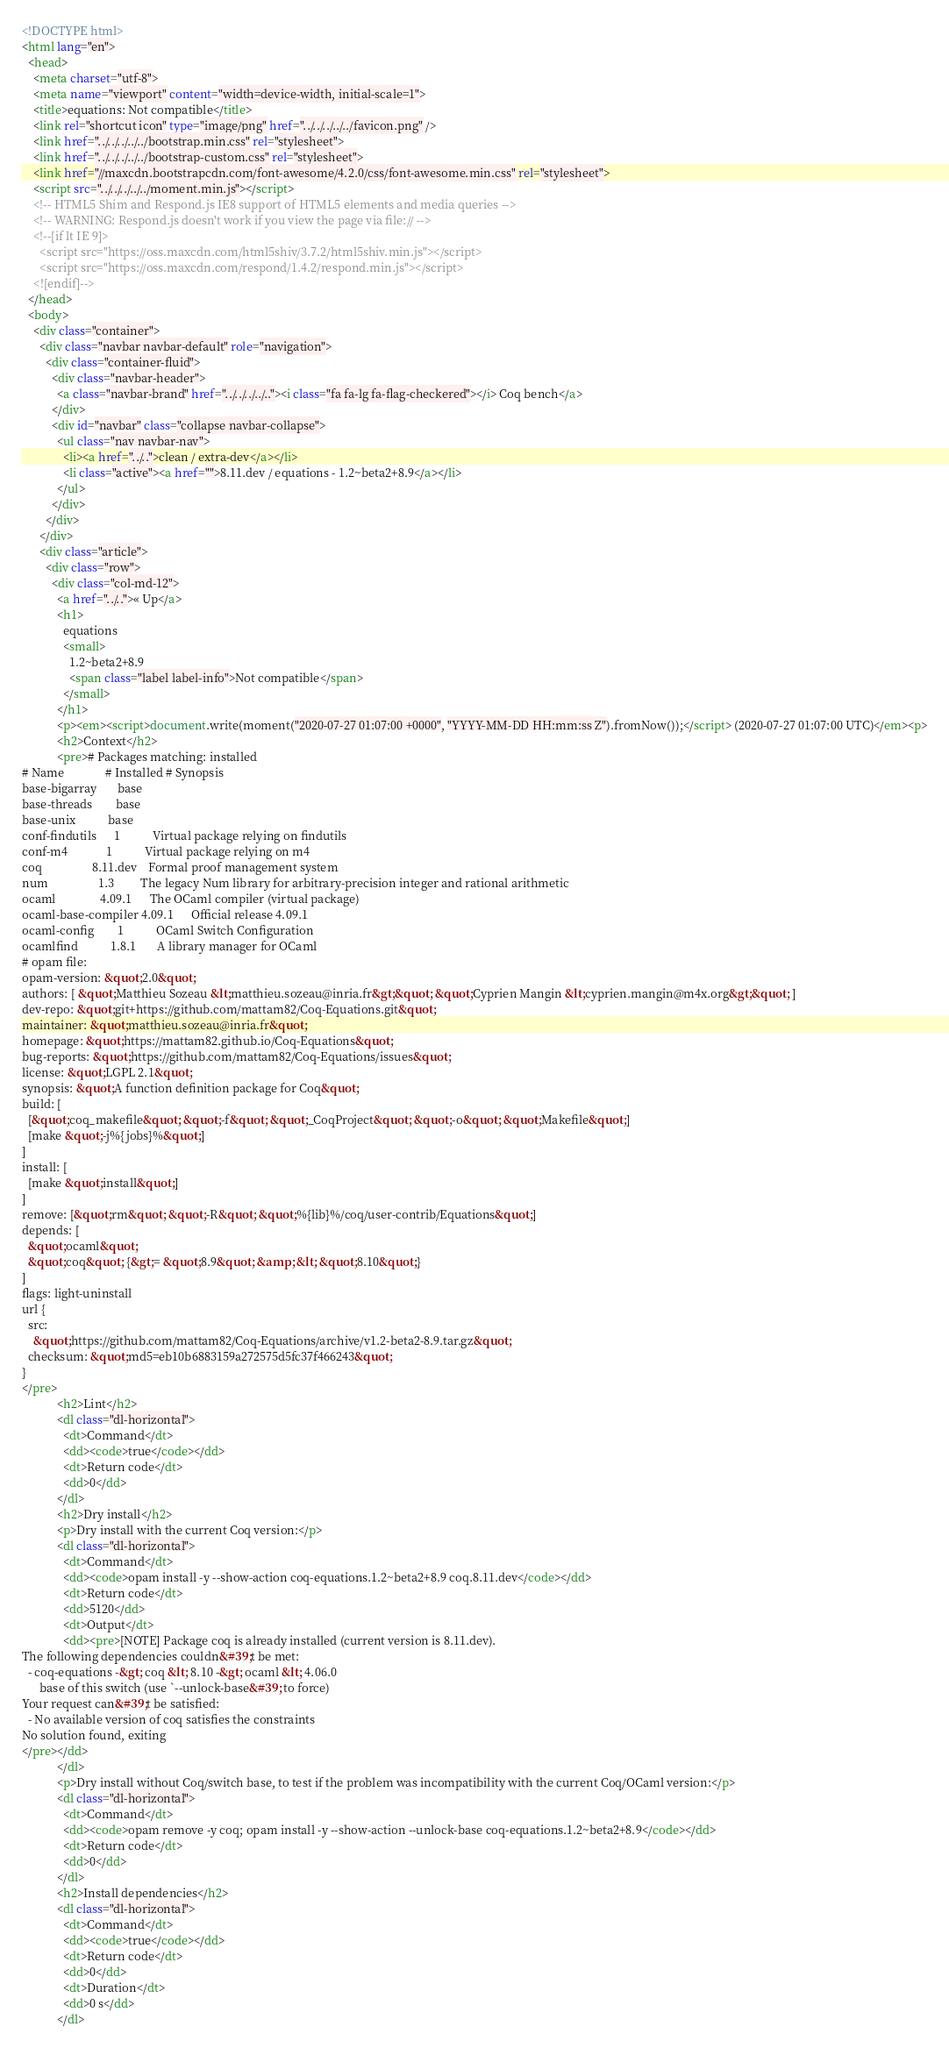Convert code to text. <code><loc_0><loc_0><loc_500><loc_500><_HTML_><!DOCTYPE html>
<html lang="en">
  <head>
    <meta charset="utf-8">
    <meta name="viewport" content="width=device-width, initial-scale=1">
    <title>equations: Not compatible</title>
    <link rel="shortcut icon" type="image/png" href="../../../../../favicon.png" />
    <link href="../../../../../bootstrap.min.css" rel="stylesheet">
    <link href="../../../../../bootstrap-custom.css" rel="stylesheet">
    <link href="//maxcdn.bootstrapcdn.com/font-awesome/4.2.0/css/font-awesome.min.css" rel="stylesheet">
    <script src="../../../../../moment.min.js"></script>
    <!-- HTML5 Shim and Respond.js IE8 support of HTML5 elements and media queries -->
    <!-- WARNING: Respond.js doesn't work if you view the page via file:// -->
    <!--[if lt IE 9]>
      <script src="https://oss.maxcdn.com/html5shiv/3.7.2/html5shiv.min.js"></script>
      <script src="https://oss.maxcdn.com/respond/1.4.2/respond.min.js"></script>
    <![endif]-->
  </head>
  <body>
    <div class="container">
      <div class="navbar navbar-default" role="navigation">
        <div class="container-fluid">
          <div class="navbar-header">
            <a class="navbar-brand" href="../../../../.."><i class="fa fa-lg fa-flag-checkered"></i> Coq bench</a>
          </div>
          <div id="navbar" class="collapse navbar-collapse">
            <ul class="nav navbar-nav">
              <li><a href="../..">clean / extra-dev</a></li>
              <li class="active"><a href="">8.11.dev / equations - 1.2~beta2+8.9</a></li>
            </ul>
          </div>
        </div>
      </div>
      <div class="article">
        <div class="row">
          <div class="col-md-12">
            <a href="../..">« Up</a>
            <h1>
              equations
              <small>
                1.2~beta2+8.9
                <span class="label label-info">Not compatible</span>
              </small>
            </h1>
            <p><em><script>document.write(moment("2020-07-27 01:07:00 +0000", "YYYY-MM-DD HH:mm:ss Z").fromNow());</script> (2020-07-27 01:07:00 UTC)</em><p>
            <h2>Context</h2>
            <pre># Packages matching: installed
# Name              # Installed # Synopsis
base-bigarray       base
base-threads        base
base-unix           base
conf-findutils      1           Virtual package relying on findutils
conf-m4             1           Virtual package relying on m4
coq                 8.11.dev    Formal proof management system
num                 1.3         The legacy Num library for arbitrary-precision integer and rational arithmetic
ocaml               4.09.1      The OCaml compiler (virtual package)
ocaml-base-compiler 4.09.1      Official release 4.09.1
ocaml-config        1           OCaml Switch Configuration
ocamlfind           1.8.1       A library manager for OCaml
# opam file:
opam-version: &quot;2.0&quot;
authors: [ &quot;Matthieu Sozeau &lt;matthieu.sozeau@inria.fr&gt;&quot; &quot;Cyprien Mangin &lt;cyprien.mangin@m4x.org&gt;&quot; ]
dev-repo: &quot;git+https://github.com/mattam82/Coq-Equations.git&quot;
maintainer: &quot;matthieu.sozeau@inria.fr&quot;
homepage: &quot;https://mattam82.github.io/Coq-Equations&quot;
bug-reports: &quot;https://github.com/mattam82/Coq-Equations/issues&quot;
license: &quot;LGPL 2.1&quot;
synopsis: &quot;A function definition package for Coq&quot;
build: [
  [&quot;coq_makefile&quot; &quot;-f&quot; &quot;_CoqProject&quot; &quot;-o&quot; &quot;Makefile&quot;]
  [make &quot;-j%{jobs}%&quot;]
]
install: [
  [make &quot;install&quot;]
]
remove: [&quot;rm&quot; &quot;-R&quot; &quot;%{lib}%/coq/user-contrib/Equations&quot;]
depends: [
  &quot;ocaml&quot;
  &quot;coq&quot; {&gt;= &quot;8.9&quot; &amp; &lt; &quot;8.10&quot;}
]
flags: light-uninstall
url {
  src:
    &quot;https://github.com/mattam82/Coq-Equations/archive/v1.2-beta2-8.9.tar.gz&quot;
  checksum: &quot;md5=eb10b6883159a272575d5fc37f466243&quot;
}
</pre>
            <h2>Lint</h2>
            <dl class="dl-horizontal">
              <dt>Command</dt>
              <dd><code>true</code></dd>
              <dt>Return code</dt>
              <dd>0</dd>
            </dl>
            <h2>Dry install</h2>
            <p>Dry install with the current Coq version:</p>
            <dl class="dl-horizontal">
              <dt>Command</dt>
              <dd><code>opam install -y --show-action coq-equations.1.2~beta2+8.9 coq.8.11.dev</code></dd>
              <dt>Return code</dt>
              <dd>5120</dd>
              <dt>Output</dt>
              <dd><pre>[NOTE] Package coq is already installed (current version is 8.11.dev).
The following dependencies couldn&#39;t be met:
  - coq-equations -&gt; coq &lt; 8.10 -&gt; ocaml &lt; 4.06.0
      base of this switch (use `--unlock-base&#39; to force)
Your request can&#39;t be satisfied:
  - No available version of coq satisfies the constraints
No solution found, exiting
</pre></dd>
            </dl>
            <p>Dry install without Coq/switch base, to test if the problem was incompatibility with the current Coq/OCaml version:</p>
            <dl class="dl-horizontal">
              <dt>Command</dt>
              <dd><code>opam remove -y coq; opam install -y --show-action --unlock-base coq-equations.1.2~beta2+8.9</code></dd>
              <dt>Return code</dt>
              <dd>0</dd>
            </dl>
            <h2>Install dependencies</h2>
            <dl class="dl-horizontal">
              <dt>Command</dt>
              <dd><code>true</code></dd>
              <dt>Return code</dt>
              <dd>0</dd>
              <dt>Duration</dt>
              <dd>0 s</dd>
            </dl></code> 